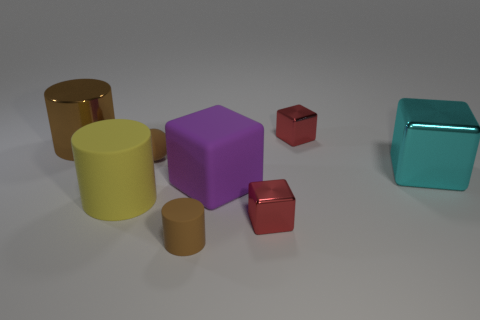Are there any shiny things that have the same size as the purple matte thing?
Make the answer very short. Yes. What size is the brown rubber sphere?
Give a very brief answer. Small. How many brown matte cylinders are the same size as the sphere?
Your answer should be very brief. 1. Is the number of tiny matte spheres behind the large purple matte object less than the number of big objects in front of the large metallic block?
Keep it short and to the point. Yes. What is the size of the block behind the shiny object on the left side of the red cube that is in front of the cyan object?
Keep it short and to the point. Small. There is a thing that is to the left of the brown rubber sphere and behind the cyan shiny object; what size is it?
Make the answer very short. Large. There is a red metal object that is in front of the big metal object in front of the brown rubber ball; what is its shape?
Offer a terse response. Cube. Is there anything else that is the same color as the large rubber block?
Provide a succinct answer. No. What shape is the yellow thing right of the brown metallic object?
Offer a very short reply. Cylinder. There is a rubber object that is in front of the large purple matte object and right of the big yellow cylinder; what shape is it?
Offer a terse response. Cylinder. 